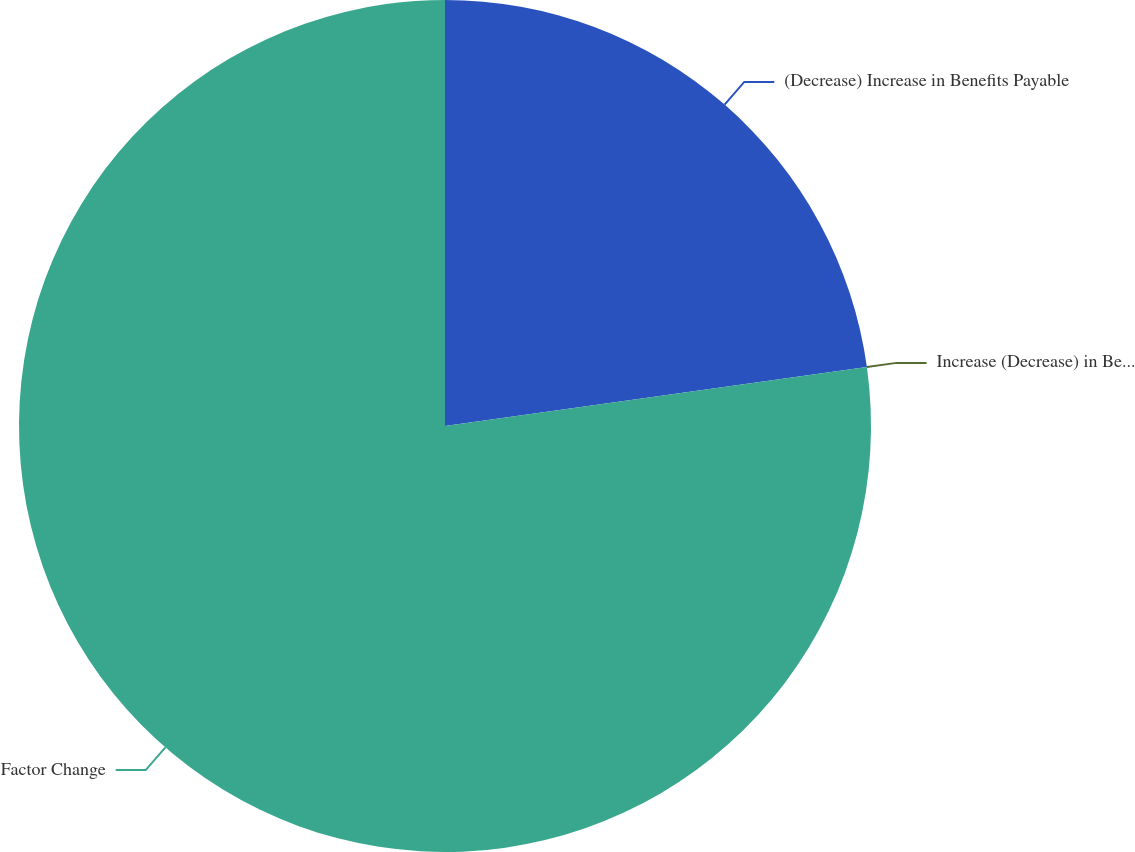Convert chart to OTSL. <chart><loc_0><loc_0><loc_500><loc_500><pie_chart><fcel>(Decrease) Increase in Benefits Payable<fcel>Increase (Decrease) in Benefits Payable<fcel>Factor Change<nl><fcel>22.79%<fcel>0.0%<fcel>77.21%<nl></chart> 